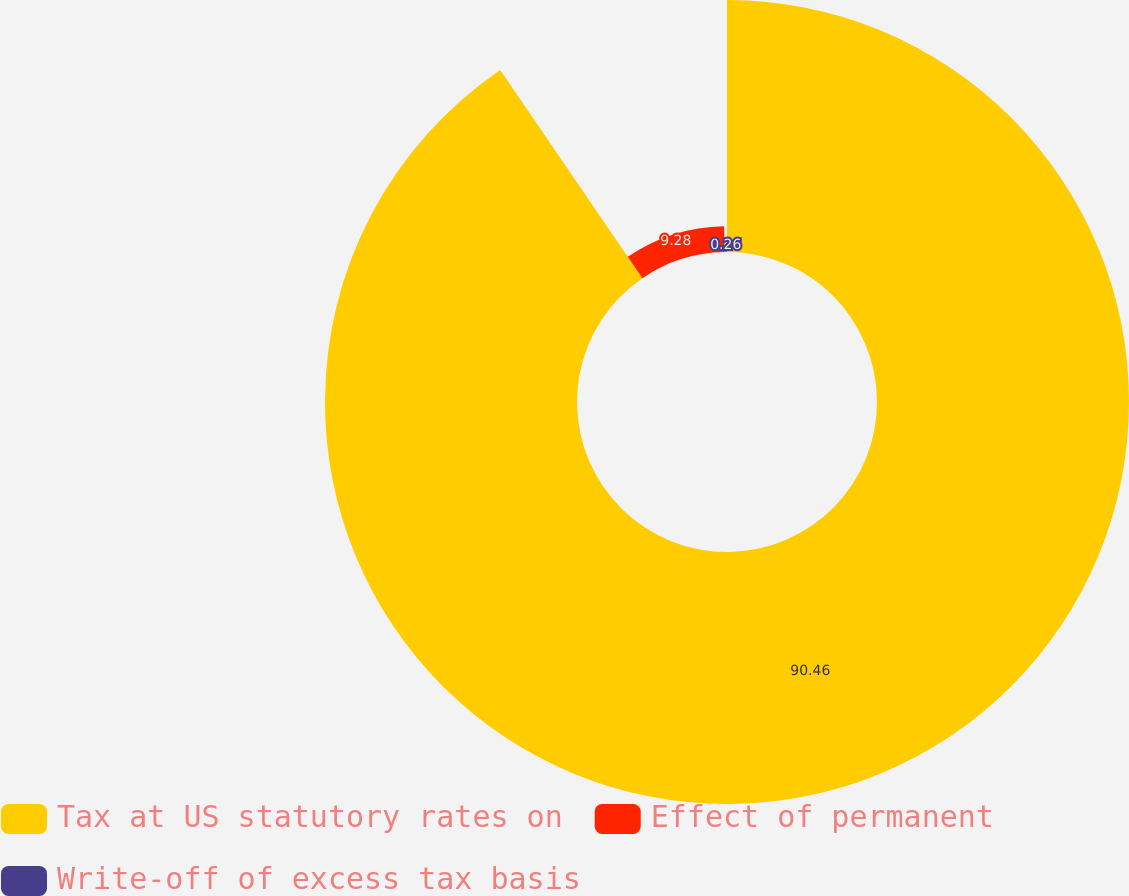Convert chart. <chart><loc_0><loc_0><loc_500><loc_500><pie_chart><fcel>Tax at US statutory rates on<fcel>Effect of permanent<fcel>Write-off of excess tax basis<nl><fcel>90.46%<fcel>9.28%<fcel>0.26%<nl></chart> 